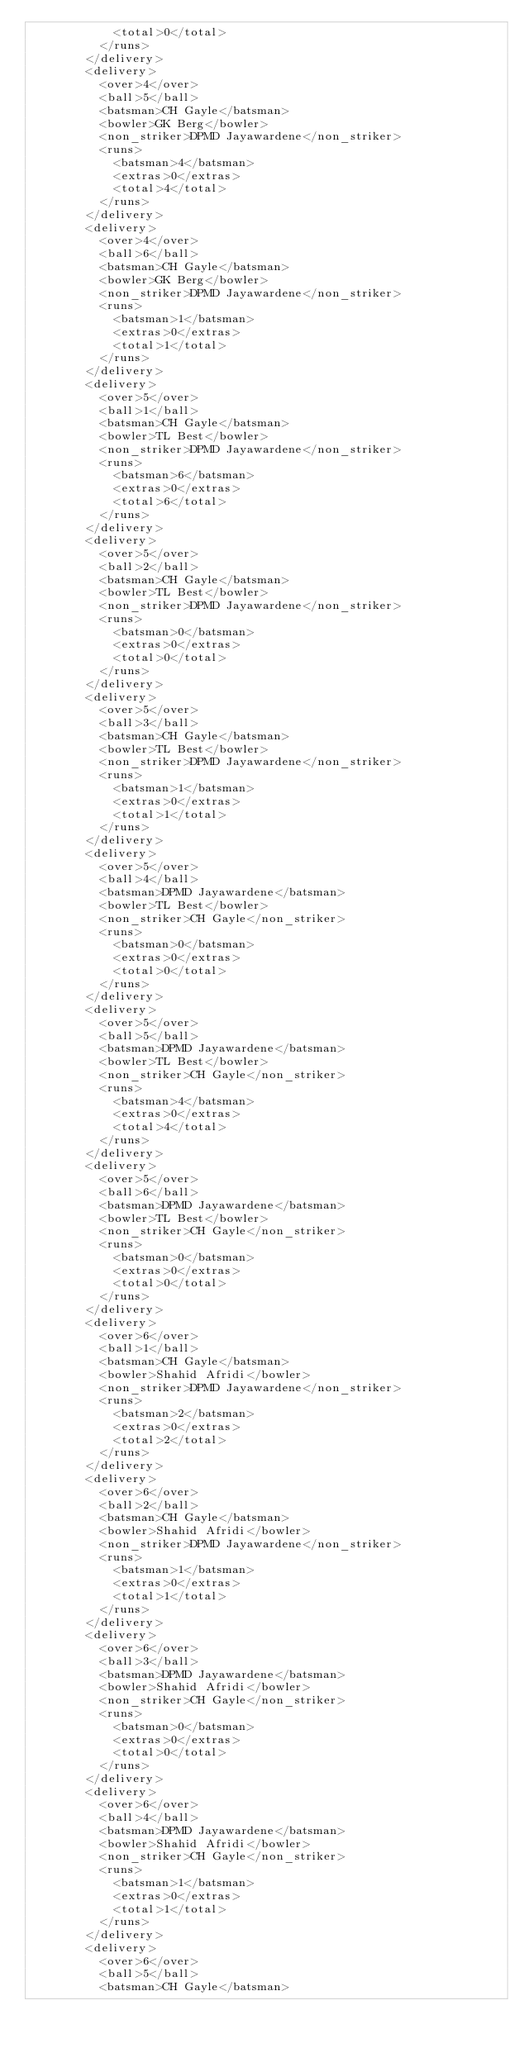Convert code to text. <code><loc_0><loc_0><loc_500><loc_500><_XML_>            <total>0</total>
          </runs>
        </delivery>
        <delivery>
          <over>4</over>
          <ball>5</ball>
          <batsman>CH Gayle</batsman>
          <bowler>GK Berg</bowler>
          <non_striker>DPMD Jayawardene</non_striker>
          <runs>
            <batsman>4</batsman>
            <extras>0</extras>
            <total>4</total>
          </runs>
        </delivery>
        <delivery>
          <over>4</over>
          <ball>6</ball>
          <batsman>CH Gayle</batsman>
          <bowler>GK Berg</bowler>
          <non_striker>DPMD Jayawardene</non_striker>
          <runs>
            <batsman>1</batsman>
            <extras>0</extras>
            <total>1</total>
          </runs>
        </delivery>
        <delivery>
          <over>5</over>
          <ball>1</ball>
          <batsman>CH Gayle</batsman>
          <bowler>TL Best</bowler>
          <non_striker>DPMD Jayawardene</non_striker>
          <runs>
            <batsman>6</batsman>
            <extras>0</extras>
            <total>6</total>
          </runs>
        </delivery>
        <delivery>
          <over>5</over>
          <ball>2</ball>
          <batsman>CH Gayle</batsman>
          <bowler>TL Best</bowler>
          <non_striker>DPMD Jayawardene</non_striker>
          <runs>
            <batsman>0</batsman>
            <extras>0</extras>
            <total>0</total>
          </runs>
        </delivery>
        <delivery>
          <over>5</over>
          <ball>3</ball>
          <batsman>CH Gayle</batsman>
          <bowler>TL Best</bowler>
          <non_striker>DPMD Jayawardene</non_striker>
          <runs>
            <batsman>1</batsman>
            <extras>0</extras>
            <total>1</total>
          </runs>
        </delivery>
        <delivery>
          <over>5</over>
          <ball>4</ball>
          <batsman>DPMD Jayawardene</batsman>
          <bowler>TL Best</bowler>
          <non_striker>CH Gayle</non_striker>
          <runs>
            <batsman>0</batsman>
            <extras>0</extras>
            <total>0</total>
          </runs>
        </delivery>
        <delivery>
          <over>5</over>
          <ball>5</ball>
          <batsman>DPMD Jayawardene</batsman>
          <bowler>TL Best</bowler>
          <non_striker>CH Gayle</non_striker>
          <runs>
            <batsman>4</batsman>
            <extras>0</extras>
            <total>4</total>
          </runs>
        </delivery>
        <delivery>
          <over>5</over>
          <ball>6</ball>
          <batsman>DPMD Jayawardene</batsman>
          <bowler>TL Best</bowler>
          <non_striker>CH Gayle</non_striker>
          <runs>
            <batsman>0</batsman>
            <extras>0</extras>
            <total>0</total>
          </runs>
        </delivery>
        <delivery>
          <over>6</over>
          <ball>1</ball>
          <batsman>CH Gayle</batsman>
          <bowler>Shahid Afridi</bowler>
          <non_striker>DPMD Jayawardene</non_striker>
          <runs>
            <batsman>2</batsman>
            <extras>0</extras>
            <total>2</total>
          </runs>
        </delivery>
        <delivery>
          <over>6</over>
          <ball>2</ball>
          <batsman>CH Gayle</batsman>
          <bowler>Shahid Afridi</bowler>
          <non_striker>DPMD Jayawardene</non_striker>
          <runs>
            <batsman>1</batsman>
            <extras>0</extras>
            <total>1</total>
          </runs>
        </delivery>
        <delivery>
          <over>6</over>
          <ball>3</ball>
          <batsman>DPMD Jayawardene</batsman>
          <bowler>Shahid Afridi</bowler>
          <non_striker>CH Gayle</non_striker>
          <runs>
            <batsman>0</batsman>
            <extras>0</extras>
            <total>0</total>
          </runs>
        </delivery>
        <delivery>
          <over>6</over>
          <ball>4</ball>
          <batsman>DPMD Jayawardene</batsman>
          <bowler>Shahid Afridi</bowler>
          <non_striker>CH Gayle</non_striker>
          <runs>
            <batsman>1</batsman>
            <extras>0</extras>
            <total>1</total>
          </runs>
        </delivery>
        <delivery>
          <over>6</over>
          <ball>5</ball>
          <batsman>CH Gayle</batsman></code> 